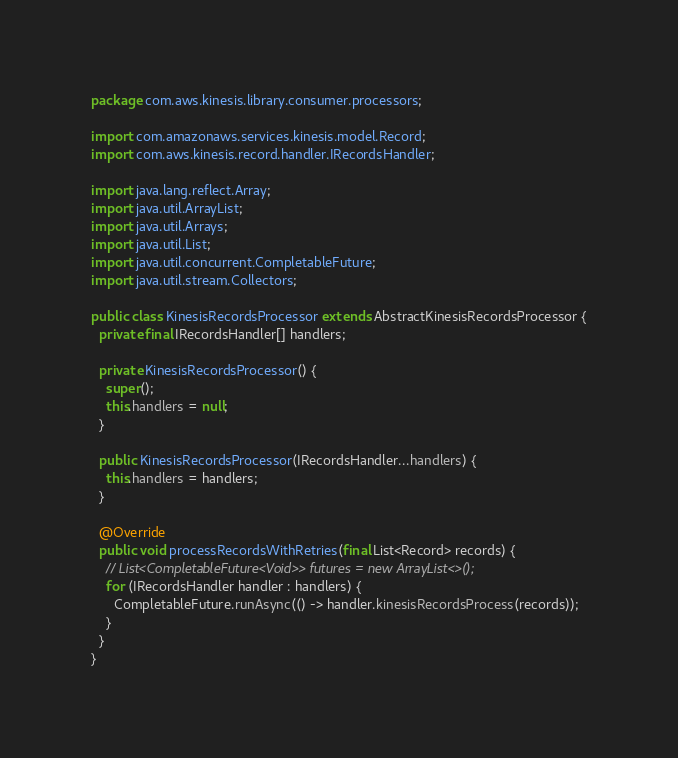<code> <loc_0><loc_0><loc_500><loc_500><_Java_>package com.aws.kinesis.library.consumer.processors;

import com.amazonaws.services.kinesis.model.Record;
import com.aws.kinesis.record.handler.IRecordsHandler;

import java.lang.reflect.Array;
import java.util.ArrayList;
import java.util.Arrays;
import java.util.List;
import java.util.concurrent.CompletableFuture;
import java.util.stream.Collectors;

public class KinesisRecordsProcessor extends AbstractKinesisRecordsProcessor {
  private final IRecordsHandler[] handlers;

  private KinesisRecordsProcessor() {
    super();
    this.handlers = null;
  }

  public KinesisRecordsProcessor(IRecordsHandler...handlers) {
    this.handlers = handlers;
  }

  @Override
  public void processRecordsWithRetries(final List<Record> records) {
    // List<CompletableFuture<Void>> futures = new ArrayList<>();
    for (IRecordsHandler handler : handlers) {
      CompletableFuture.runAsync(() -> handler.kinesisRecordsProcess(records));
    }
  }
}
</code> 